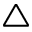<formula> <loc_0><loc_0><loc_500><loc_500>\triangle</formula> 